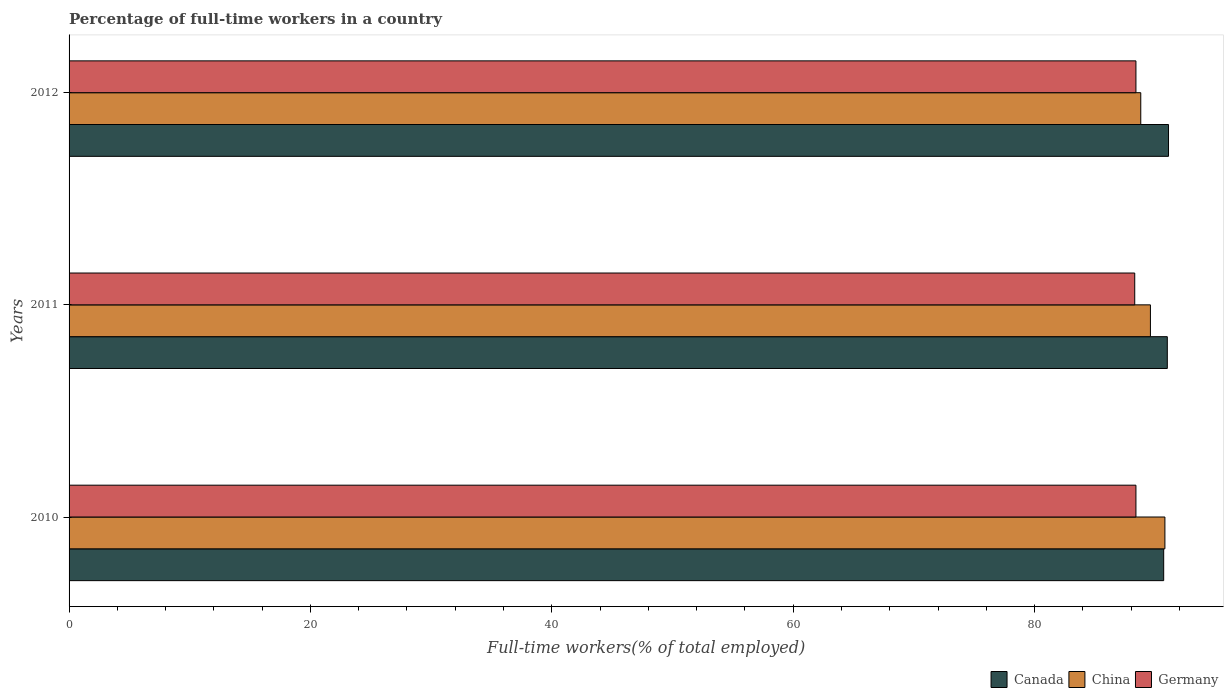How many different coloured bars are there?
Ensure brevity in your answer.  3. How many groups of bars are there?
Your answer should be very brief. 3. Are the number of bars on each tick of the Y-axis equal?
Provide a short and direct response. Yes. What is the percentage of full-time workers in China in 2012?
Provide a succinct answer. 88.8. Across all years, what is the maximum percentage of full-time workers in Canada?
Ensure brevity in your answer.  91.1. Across all years, what is the minimum percentage of full-time workers in Canada?
Your answer should be very brief. 90.7. In which year was the percentage of full-time workers in Germany maximum?
Offer a very short reply. 2010. What is the total percentage of full-time workers in Canada in the graph?
Offer a terse response. 272.8. What is the difference between the percentage of full-time workers in Germany in 2011 and that in 2012?
Keep it short and to the point. -0.1. What is the difference between the percentage of full-time workers in China in 2011 and the percentage of full-time workers in Canada in 2012?
Your answer should be very brief. -1.5. What is the average percentage of full-time workers in Germany per year?
Your answer should be compact. 88.37. In the year 2011, what is the difference between the percentage of full-time workers in China and percentage of full-time workers in Canada?
Offer a very short reply. -1.4. In how many years, is the percentage of full-time workers in Canada greater than 12 %?
Offer a very short reply. 3. What is the ratio of the percentage of full-time workers in Canada in 2010 to that in 2011?
Offer a terse response. 1. Is the percentage of full-time workers in Germany in 2010 less than that in 2012?
Make the answer very short. No. Is the difference between the percentage of full-time workers in China in 2010 and 2012 greater than the difference between the percentage of full-time workers in Canada in 2010 and 2012?
Make the answer very short. Yes. What is the difference between the highest and the second highest percentage of full-time workers in Germany?
Offer a terse response. 0. In how many years, is the percentage of full-time workers in Canada greater than the average percentage of full-time workers in Canada taken over all years?
Ensure brevity in your answer.  2. Is the sum of the percentage of full-time workers in Canada in 2010 and 2012 greater than the maximum percentage of full-time workers in Germany across all years?
Make the answer very short. Yes. What does the 2nd bar from the top in 2010 represents?
Your answer should be very brief. China. Where does the legend appear in the graph?
Provide a short and direct response. Bottom right. How many legend labels are there?
Keep it short and to the point. 3. How are the legend labels stacked?
Give a very brief answer. Horizontal. What is the title of the graph?
Your answer should be compact. Percentage of full-time workers in a country. Does "Bhutan" appear as one of the legend labels in the graph?
Provide a short and direct response. No. What is the label or title of the X-axis?
Your answer should be compact. Full-time workers(% of total employed). What is the Full-time workers(% of total employed) in Canada in 2010?
Your answer should be compact. 90.7. What is the Full-time workers(% of total employed) of China in 2010?
Provide a succinct answer. 90.8. What is the Full-time workers(% of total employed) of Germany in 2010?
Provide a short and direct response. 88.4. What is the Full-time workers(% of total employed) of Canada in 2011?
Your response must be concise. 91. What is the Full-time workers(% of total employed) in China in 2011?
Provide a succinct answer. 89.6. What is the Full-time workers(% of total employed) of Germany in 2011?
Ensure brevity in your answer.  88.3. What is the Full-time workers(% of total employed) in Canada in 2012?
Provide a short and direct response. 91.1. What is the Full-time workers(% of total employed) of China in 2012?
Make the answer very short. 88.8. What is the Full-time workers(% of total employed) in Germany in 2012?
Provide a short and direct response. 88.4. Across all years, what is the maximum Full-time workers(% of total employed) in Canada?
Offer a very short reply. 91.1. Across all years, what is the maximum Full-time workers(% of total employed) of China?
Your answer should be very brief. 90.8. Across all years, what is the maximum Full-time workers(% of total employed) in Germany?
Your answer should be compact. 88.4. Across all years, what is the minimum Full-time workers(% of total employed) in Canada?
Provide a short and direct response. 90.7. Across all years, what is the minimum Full-time workers(% of total employed) of China?
Your answer should be compact. 88.8. Across all years, what is the minimum Full-time workers(% of total employed) of Germany?
Make the answer very short. 88.3. What is the total Full-time workers(% of total employed) in Canada in the graph?
Offer a very short reply. 272.8. What is the total Full-time workers(% of total employed) of China in the graph?
Your answer should be very brief. 269.2. What is the total Full-time workers(% of total employed) in Germany in the graph?
Give a very brief answer. 265.1. What is the difference between the Full-time workers(% of total employed) of Canada in 2010 and that in 2011?
Your response must be concise. -0.3. What is the difference between the Full-time workers(% of total employed) in China in 2010 and that in 2011?
Your response must be concise. 1.2. What is the difference between the Full-time workers(% of total employed) in Germany in 2010 and that in 2012?
Keep it short and to the point. 0. What is the difference between the Full-time workers(% of total employed) of Canada in 2011 and that in 2012?
Ensure brevity in your answer.  -0.1. What is the difference between the Full-time workers(% of total employed) in China in 2011 and that in 2012?
Provide a succinct answer. 0.8. What is the difference between the Full-time workers(% of total employed) in Germany in 2011 and that in 2012?
Make the answer very short. -0.1. What is the difference between the Full-time workers(% of total employed) in Canada in 2011 and the Full-time workers(% of total employed) in China in 2012?
Your response must be concise. 2.2. What is the difference between the Full-time workers(% of total employed) of China in 2011 and the Full-time workers(% of total employed) of Germany in 2012?
Your answer should be compact. 1.2. What is the average Full-time workers(% of total employed) in Canada per year?
Your answer should be compact. 90.93. What is the average Full-time workers(% of total employed) in China per year?
Make the answer very short. 89.73. What is the average Full-time workers(% of total employed) of Germany per year?
Give a very brief answer. 88.37. In the year 2010, what is the difference between the Full-time workers(% of total employed) in China and Full-time workers(% of total employed) in Germany?
Your answer should be compact. 2.4. In the year 2011, what is the difference between the Full-time workers(% of total employed) in Canada and Full-time workers(% of total employed) in China?
Make the answer very short. 1.4. In the year 2011, what is the difference between the Full-time workers(% of total employed) in China and Full-time workers(% of total employed) in Germany?
Give a very brief answer. 1.3. In the year 2012, what is the difference between the Full-time workers(% of total employed) of Canada and Full-time workers(% of total employed) of China?
Make the answer very short. 2.3. In the year 2012, what is the difference between the Full-time workers(% of total employed) in Canada and Full-time workers(% of total employed) in Germany?
Your answer should be compact. 2.7. In the year 2012, what is the difference between the Full-time workers(% of total employed) of China and Full-time workers(% of total employed) of Germany?
Ensure brevity in your answer.  0.4. What is the ratio of the Full-time workers(% of total employed) of China in 2010 to that in 2011?
Keep it short and to the point. 1.01. What is the ratio of the Full-time workers(% of total employed) in Germany in 2010 to that in 2011?
Offer a terse response. 1. What is the ratio of the Full-time workers(% of total employed) in China in 2010 to that in 2012?
Your answer should be very brief. 1.02. What is the ratio of the Full-time workers(% of total employed) of Germany in 2010 to that in 2012?
Your answer should be compact. 1. What is the difference between the highest and the second highest Full-time workers(% of total employed) of Canada?
Provide a succinct answer. 0.1. What is the difference between the highest and the second highest Full-time workers(% of total employed) in Germany?
Offer a terse response. 0. What is the difference between the highest and the lowest Full-time workers(% of total employed) in China?
Your answer should be very brief. 2. What is the difference between the highest and the lowest Full-time workers(% of total employed) in Germany?
Make the answer very short. 0.1. 